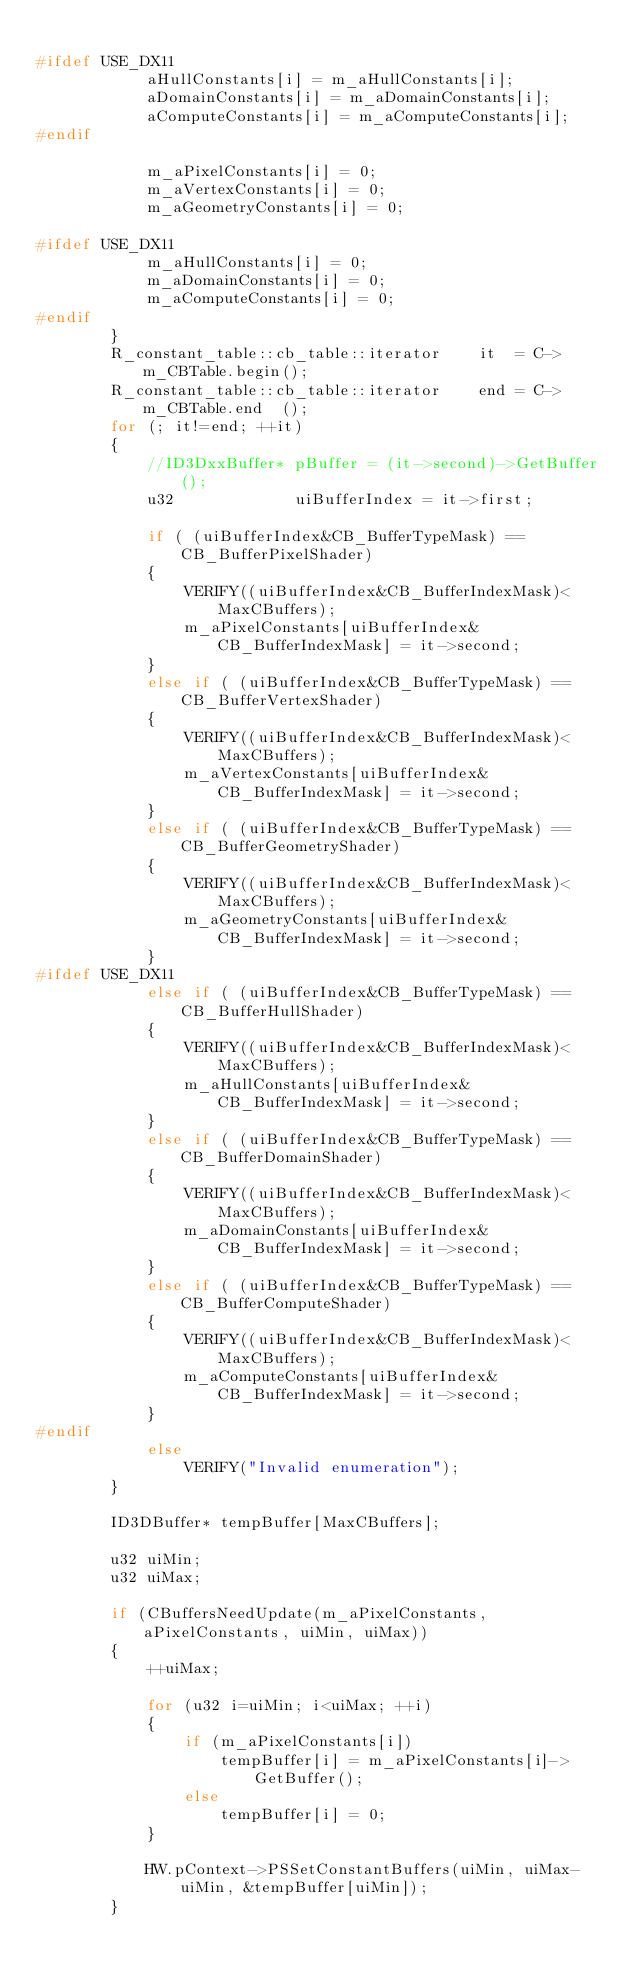Convert code to text. <code><loc_0><loc_0><loc_500><loc_500><_C_>
#ifdef USE_DX11
			aHullConstants[i] = m_aHullConstants[i];
			aDomainConstants[i] = m_aDomainConstants[i];
			aComputeConstants[i] = m_aComputeConstants[i];
#endif

			m_aPixelConstants[i] = 0;
			m_aVertexConstants[i] = 0;
			m_aGeometryConstants[i] = 0;

#ifdef USE_DX11
			m_aHullConstants[i] = 0;
			m_aDomainConstants[i] = 0;
			m_aComputeConstants[i] = 0;
#endif
		}
		R_constant_table::cb_table::iterator	it	= C->m_CBTable.begin();
		R_constant_table::cb_table::iterator	end	= C->m_CBTable.end	();
		for (; it!=end; ++it)
		{
			//ID3DxxBuffer*	pBuffer = (it->second)->GetBuffer();
			u32				uiBufferIndex = it->first; 

			if ( (uiBufferIndex&CB_BufferTypeMask) == CB_BufferPixelShader)
			{
				VERIFY((uiBufferIndex&CB_BufferIndexMask)<MaxCBuffers);
				m_aPixelConstants[uiBufferIndex&CB_BufferIndexMask] = it->second;
			}
			else if ( (uiBufferIndex&CB_BufferTypeMask) == CB_BufferVertexShader)
			{
				VERIFY((uiBufferIndex&CB_BufferIndexMask)<MaxCBuffers);
				m_aVertexConstants[uiBufferIndex&CB_BufferIndexMask] = it->second;
			}
			else if ( (uiBufferIndex&CB_BufferTypeMask) == CB_BufferGeometryShader)
			{
				VERIFY((uiBufferIndex&CB_BufferIndexMask)<MaxCBuffers);
				m_aGeometryConstants[uiBufferIndex&CB_BufferIndexMask] = it->second;
			}
#ifdef USE_DX11
			else if ( (uiBufferIndex&CB_BufferTypeMask) == CB_BufferHullShader)
			{
				VERIFY((uiBufferIndex&CB_BufferIndexMask)<MaxCBuffers);
				m_aHullConstants[uiBufferIndex&CB_BufferIndexMask] = it->second;
			}
			else if ( (uiBufferIndex&CB_BufferTypeMask) == CB_BufferDomainShader)
			{
				VERIFY((uiBufferIndex&CB_BufferIndexMask)<MaxCBuffers);
				m_aDomainConstants[uiBufferIndex&CB_BufferIndexMask] = it->second;
			}
			else if ( (uiBufferIndex&CB_BufferTypeMask) == CB_BufferComputeShader)
			{
				VERIFY((uiBufferIndex&CB_BufferIndexMask)<MaxCBuffers);
				m_aComputeConstants[uiBufferIndex&CB_BufferIndexMask] = it->second;
			}
#endif
			else
				VERIFY("Invalid enumeration");
		}

		ID3DBuffer*	tempBuffer[MaxCBuffers];

		u32 uiMin;
		u32 uiMax;

		if (CBuffersNeedUpdate(m_aPixelConstants, aPixelConstants, uiMin, uiMax))
		{
			++uiMax;

			for (u32 i=uiMin; i<uiMax; ++i)
			{
				if (m_aPixelConstants[i])
					tempBuffer[i] = m_aPixelConstants[i]->GetBuffer();
				else
					tempBuffer[i] = 0;
			}

			HW.pContext->PSSetConstantBuffers(uiMin, uiMax-uiMin, &tempBuffer[uiMin]);
		}
		
</code> 